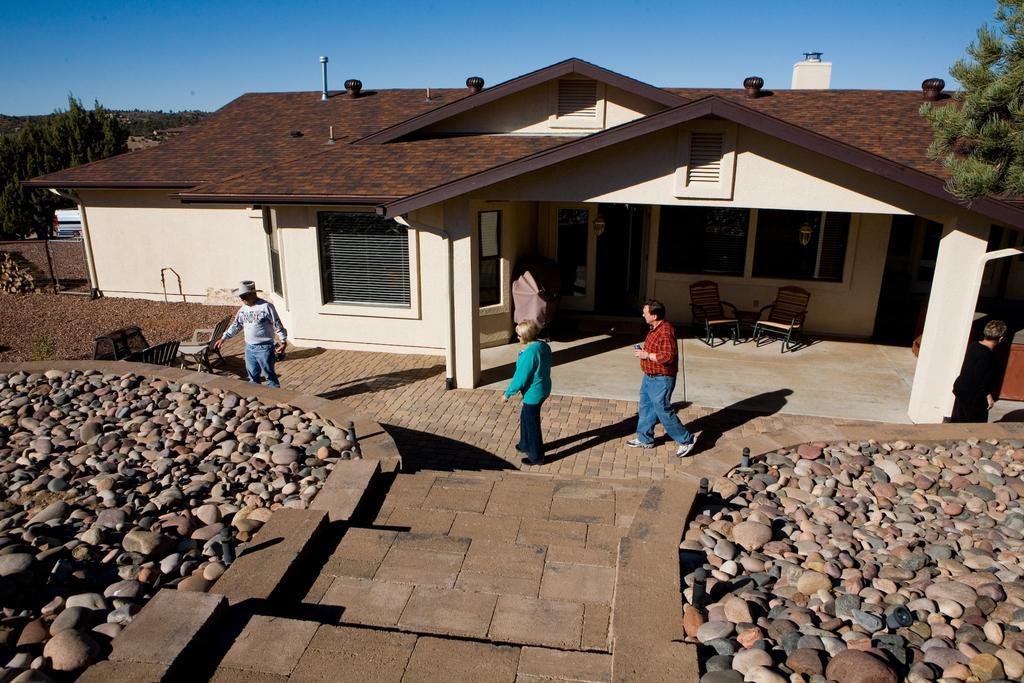In one or two sentences, can you explain what this image depicts? In this image we can see a few people, there are chairs, there is a house, windows, there are rocks, trees, also we can see the sky. 